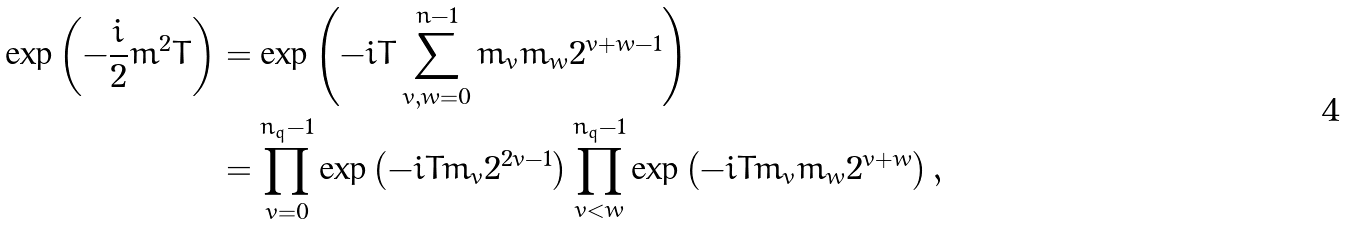<formula> <loc_0><loc_0><loc_500><loc_500>\exp \left ( - \frac { i } { 2 } m ^ { 2 } T \right ) & = \exp \left ( - i T \sum _ { v , w = 0 } ^ { n - 1 } m _ { v } m _ { w } 2 ^ { v + w - 1 } \right ) \\ & = \prod _ { v = 0 } ^ { n _ { q } - 1 } \exp \left ( - i T m _ { v } 2 ^ { 2 v - 1 } \right ) \prod _ { v < w } ^ { n _ { q } - 1 } \exp \left ( - i T m _ { v } m _ { w } 2 ^ { v + w } \right ) ,</formula> 